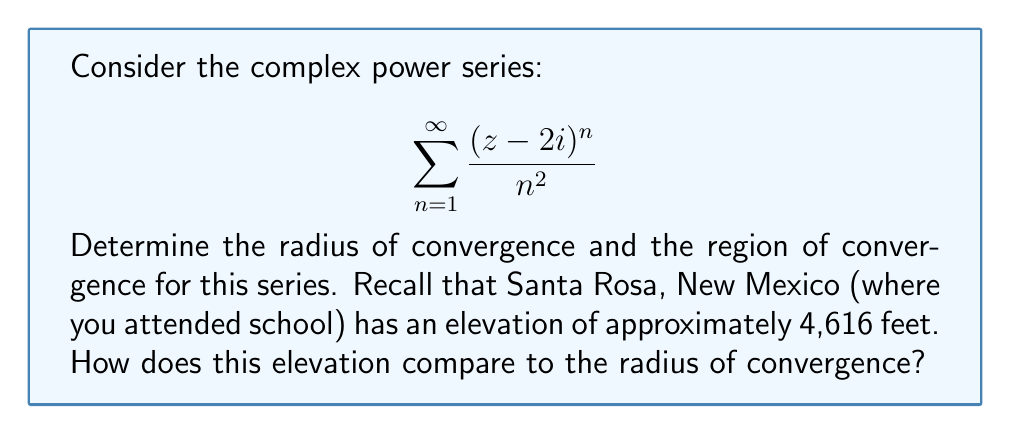Give your solution to this math problem. Let's approach this step-by-step:

1) To find the radius of convergence, we can use the ratio test:

   $$R = \lim_{n \to \infty} \left|\frac{a_n}{a_{n+1}}\right|$$

   where $a_n = \frac{(z-2i)^n}{n^2}$

2) Let's calculate this limit:

   $$\begin{align}
   R &= \lim_{n \to \infty} \left|\frac{\frac{(z-2i)^n}{n^2}}{\frac{(z-2i)^{n+1}}{(n+1)^2}}\right| \\
   &= \lim_{n \to \infty} \left|\frac{(n+1)^2}{n^2} \cdot \frac{1}{z-2i}\right| \\
   &= \lim_{n \to \infty} \left|\frac{n^2 + 2n + 1}{n^2} \cdot \frac{1}{z-2i}\right| \\
   &= \left|\frac{1}{z-2i}\right| \cdot \lim_{n \to \infty} \left(1 + \frac{2}{n} + \frac{1}{n^2}\right) \\
   &= \left|\frac{1}{z-2i}\right| \cdot 1 = \left|\frac{1}{z-2i}\right|
   \end{align}$$

3) The radius of convergence is the reciprocal of this:

   $$R = \left|\frac{1}{z-2i}\right|^{-1} = |z-2i| = 1$$

4) This means the series converges for all $z$ such that $|z-2i| < 1$, and diverges for all $z$ such that $|z-2i| > 1$.

5) The region of convergence is therefore a circle in the complex plane, centered at $2i$ with radius 1.

6) The elevation of Santa Rosa (4,616 feet) is much larger than the radius of convergence (1 unit in the complex plane). However, these quantities have different units and dimensions, so a direct comparison is not meaningful in this context.
Answer: Radius of convergence: 1. Region of convergence: $|z-2i| < 1$. 